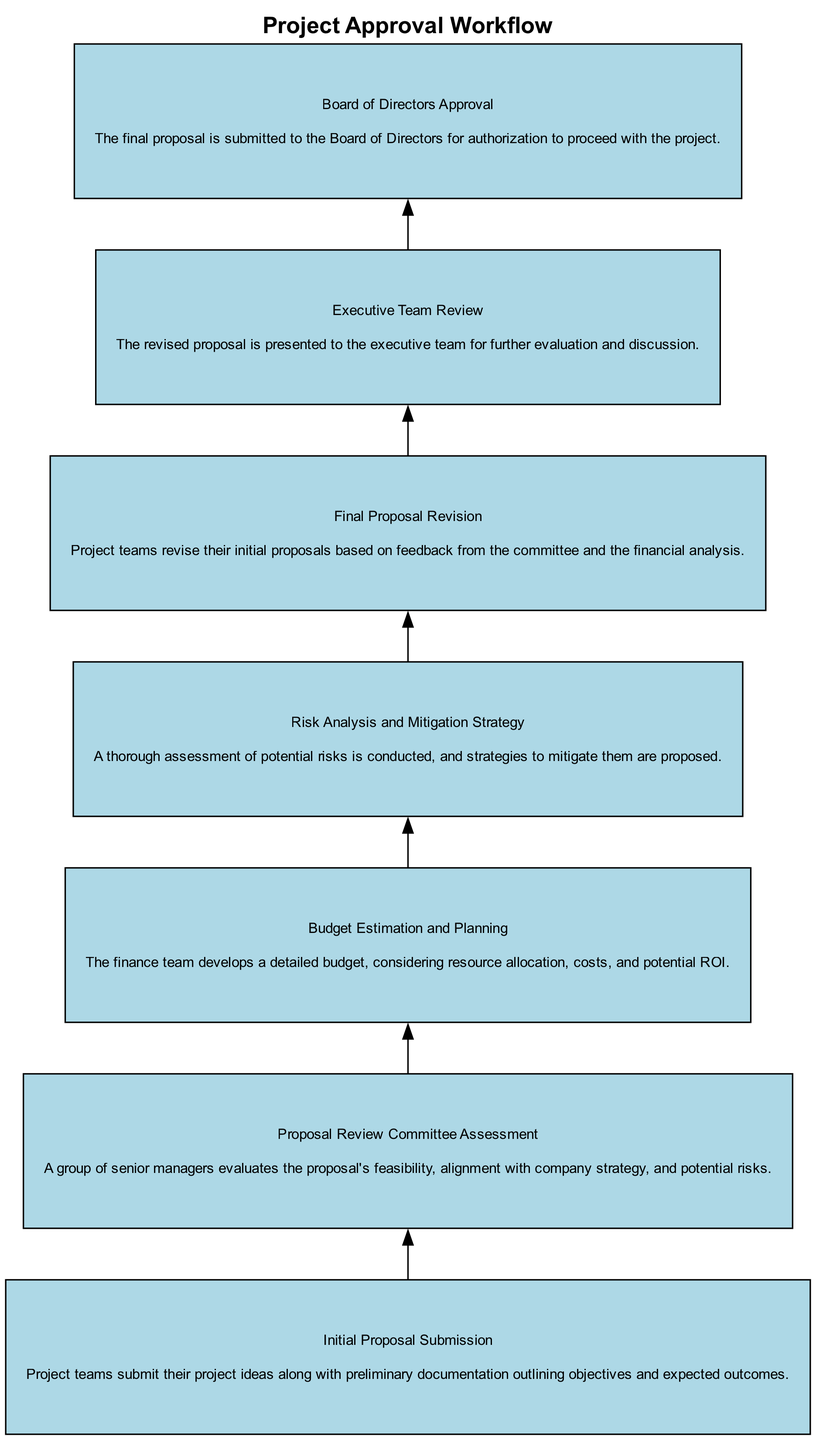What is the first stage of the project approval workflow? The first stage is "Initial Proposal Submission", which is where project teams submit their project ideas along with preliminary documentation.
Answer: Initial Proposal Submission How many stages are in the project approval workflow? There are a total of seven stages listed in the diagram of the project approval workflow.
Answer: Seven Which stage follows "Budget Estimation and Planning"? After "Budget Estimation and Planning", the following stage is "Risk Analysis and Mitigation Strategy".
Answer: Risk Analysis and Mitigation Strategy What is the focus of the "Proposal Review Committee Assessment"? The focus of this stage is on evaluating the proposal's feasibility, alignment with company strategy, and potential risks.
Answer: Evaluating feasibility and risks What is the final step before board approval? The final step before board approval is the "Executive Team Review".
Answer: Executive Team Review How does the diagram flow from "Final Proposal Revision" to "Board of Directors Approval"? The flow indicates that after making revisions based on feedback, the proposal proceeds to "Executive Team Review", and then to "Board of Directors Approval".
Answer: Executive Team Review What is the purpose of the "Risk Analysis and Mitigation Strategy"? The purpose is to conduct a thorough risk assessment and propose strategies to mitigate identified risks.
Answer: Risk assessment and mitigation strategy What stage requires a detailed budget to be developed? The stage that requires a detailed budget to be developed is "Budget Estimation and Planning".
Answer: Budget Estimation and Planning 